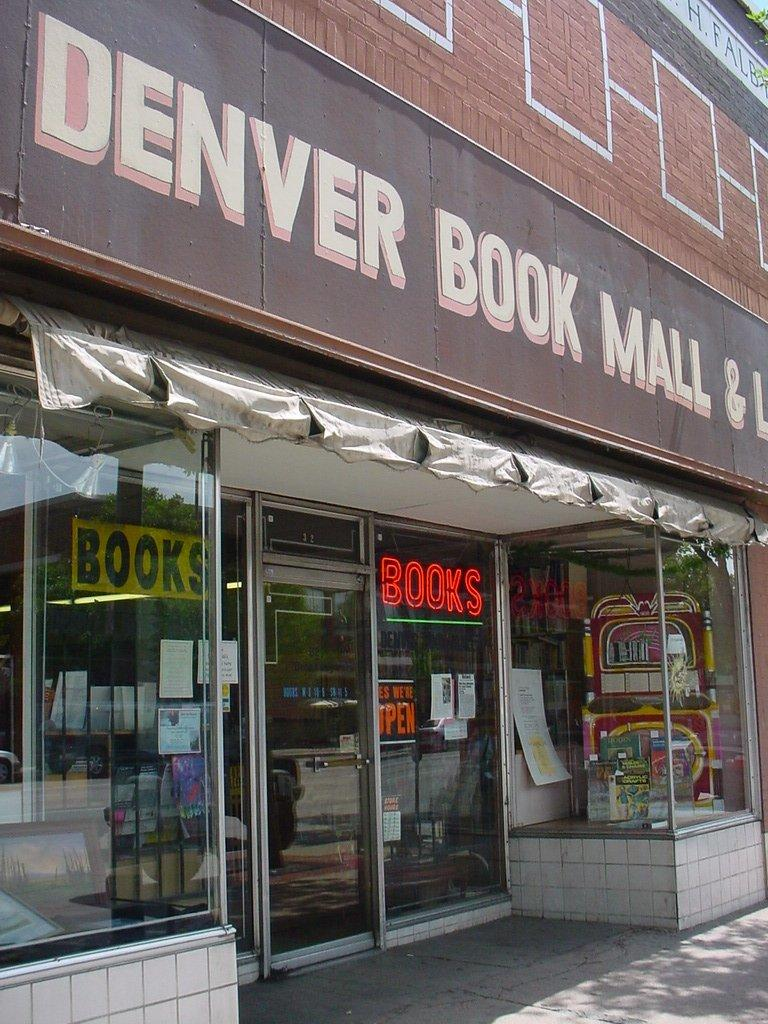<image>
Give a short and clear explanation of the subsequent image. A bookstore front with a neon books sign and a large sign that reads Denver Book Mall overhead. 